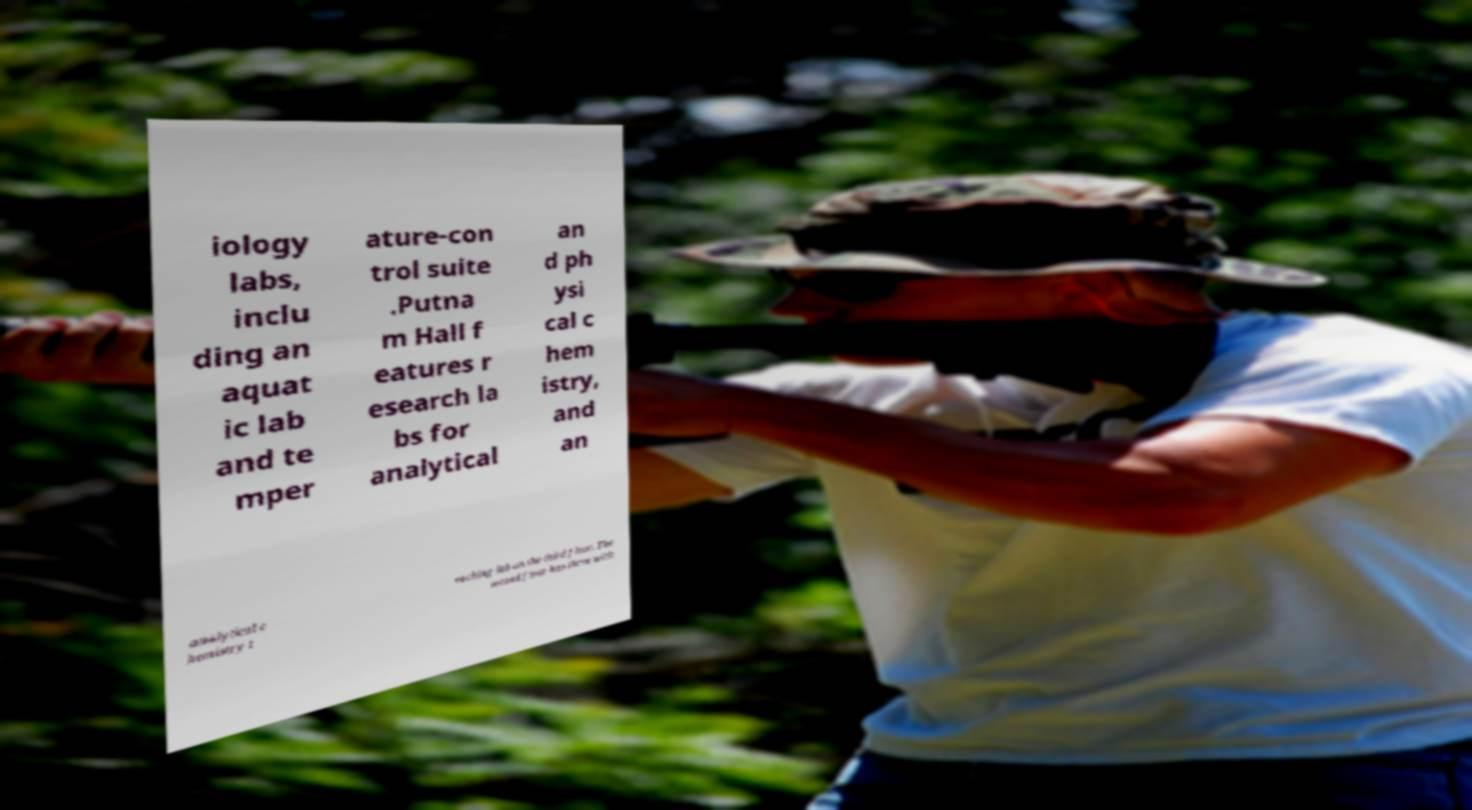Please read and relay the text visible in this image. What does it say? iology labs, inclu ding an aquat ic lab and te mper ature-con trol suite .Putna m Hall f eatures r esearch la bs for analytical an d ph ysi cal c hem istry, and an analytical c hemistry t eaching lab on the third floor. The second floor has three with 